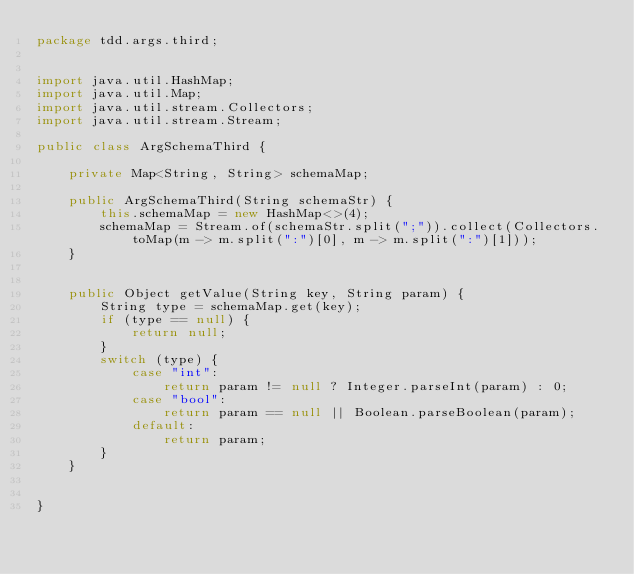Convert code to text. <code><loc_0><loc_0><loc_500><loc_500><_Java_>package tdd.args.third;


import java.util.HashMap;
import java.util.Map;
import java.util.stream.Collectors;
import java.util.stream.Stream;

public class ArgSchemaThird {

    private Map<String, String> schemaMap;

    public ArgSchemaThird(String schemaStr) {
        this.schemaMap = new HashMap<>(4);
        schemaMap = Stream.of(schemaStr.split(";")).collect(Collectors.toMap(m -> m.split(":")[0], m -> m.split(":")[1]));
    }


    public Object getValue(String key, String param) {
        String type = schemaMap.get(key);
        if (type == null) {
            return null;
        }
        switch (type) {
            case "int":
                return param != null ? Integer.parseInt(param) : 0;
            case "bool":
                return param == null || Boolean.parseBoolean(param);
            default:
                return param;
        }
    }


}
</code> 